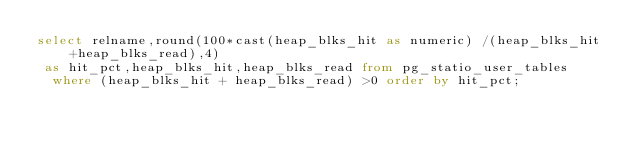<code> <loc_0><loc_0><loc_500><loc_500><_SQL_>select relname,round(100*cast(heap_blks_hit as numeric) /(heap_blks_hit +heap_blks_read),4) 
 as hit_pct,heap_blks_hit,heap_blks_read from pg_statio_user_tables 
  where (heap_blks_hit + heap_blks_read) >0 order by hit_pct;</code> 